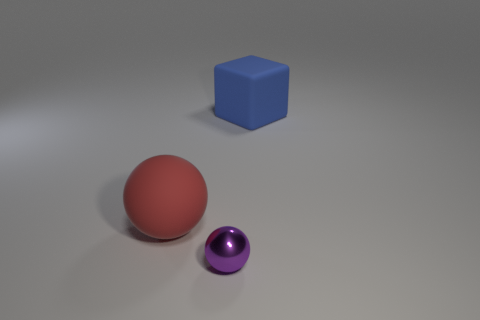Subtract all cubes. How many objects are left? 2 Add 2 big cubes. How many objects exist? 5 Subtract all tiny gray metallic objects. Subtract all big objects. How many objects are left? 1 Add 2 small purple spheres. How many small purple spheres are left? 3 Add 2 gray rubber spheres. How many gray rubber spheres exist? 2 Subtract 0 cyan balls. How many objects are left? 3 